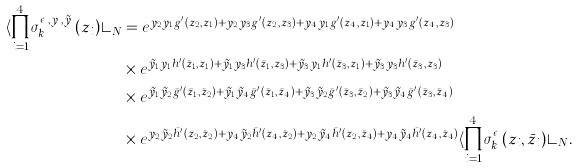Convert formula to latex. <formula><loc_0><loc_0><loc_500><loc_500>\langle \prod _ { i = 1 } ^ { 4 } \sigma _ { k _ { i } } ^ { \epsilon _ { i } , y _ { i } , \tilde { y } _ { i } } ( z _ { i } ) \rangle _ { N } & = e ^ { y _ { 2 } y _ { 1 } g ^ { \prime } ( z _ { 2 } , z _ { 1 } ) + y _ { 2 } y _ { 3 } g ^ { \prime } ( z _ { 2 } , z _ { 3 } ) + y _ { 4 } y _ { 1 } g ^ { \prime } ( z _ { 4 } , z _ { 1 } ) + y _ { 4 } y _ { 3 } g ^ { \prime } ( z _ { 4 } , z _ { 3 } ) } \\ & \times e ^ { \tilde { y } _ { 1 } y _ { 1 } h ^ { \prime } ( \bar { z } _ { 1 } , z _ { 1 } ) + \tilde { y } _ { 1 } y _ { 3 } h ^ { \prime } ( \bar { z } _ { 1 } , z _ { 3 } ) + \tilde { y } _ { 3 } y _ { 1 } h ^ { \prime } ( \bar { z } _ { 3 } , z _ { 1 } ) + \tilde { y } _ { 3 } y _ { 3 } h ^ { \prime } ( \bar { z } _ { 3 } , z _ { 3 } ) } \\ & \times e ^ { \tilde { y } _ { 1 } \tilde { y } _ { 2 } \bar { g } ^ { \prime } ( \bar { z } _ { 1 } , \bar { z } _ { 2 } ) + \tilde { y } _ { 1 } \tilde { y } _ { 4 } \bar { g } ^ { \prime } ( \bar { z } _ { 1 } , \bar { z } _ { 4 } ) + \tilde { y } _ { 3 } \tilde { y } _ { 2 } \bar { g } ^ { \prime } ( \bar { z } _ { 3 } , \bar { z } _ { 2 } ) + \tilde { y } _ { 3 } \tilde { y } _ { 4 } \bar { g } ^ { \prime } ( \bar { z } _ { 3 } , \bar { z } _ { 4 } ) } \\ & \times e ^ { y _ { 2 } \tilde { y } _ { 2 } \bar { h } ^ { \prime } ( z _ { 2 } , \bar { z } _ { 2 } ) + y _ { 4 } \tilde { y } _ { 2 } \bar { h } ^ { \prime } ( z _ { 4 } , \bar { z } _ { 2 } ) + y _ { 2 } \tilde { y } _ { 4 } \bar { h } ^ { \prime } ( z _ { 2 } , \bar { z } _ { 4 } ) + y _ { 4 } \tilde { y } _ { 4 } \bar { h } ^ { \prime } ( z _ { 4 } , \bar { z } _ { 4 } ) } \langle \prod _ { i = 1 } ^ { 4 } \sigma ^ { \epsilon _ { i } } _ { k _ { i } } ( z _ { i } , \bar { z } _ { i } ) \rangle _ { N } .</formula> 